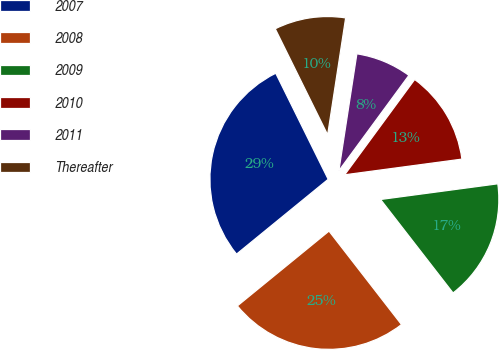Convert chart to OTSL. <chart><loc_0><loc_0><loc_500><loc_500><pie_chart><fcel>2007<fcel>2008<fcel>2009<fcel>2010<fcel>2011<fcel>Thereafter<nl><fcel>28.59%<fcel>24.6%<fcel>16.62%<fcel>12.8%<fcel>7.65%<fcel>9.74%<nl></chart> 